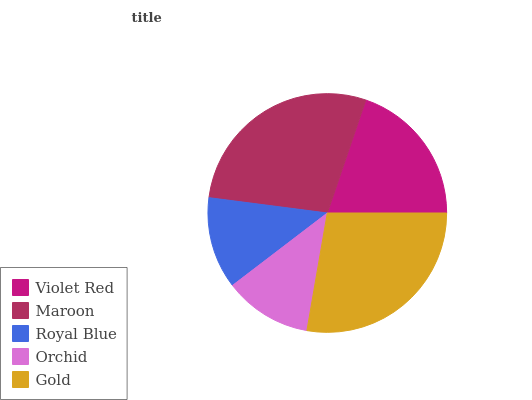Is Orchid the minimum?
Answer yes or no. Yes. Is Maroon the maximum?
Answer yes or no. Yes. Is Royal Blue the minimum?
Answer yes or no. No. Is Royal Blue the maximum?
Answer yes or no. No. Is Maroon greater than Royal Blue?
Answer yes or no. Yes. Is Royal Blue less than Maroon?
Answer yes or no. Yes. Is Royal Blue greater than Maroon?
Answer yes or no. No. Is Maroon less than Royal Blue?
Answer yes or no. No. Is Violet Red the high median?
Answer yes or no. Yes. Is Violet Red the low median?
Answer yes or no. Yes. Is Gold the high median?
Answer yes or no. No. Is Royal Blue the low median?
Answer yes or no. No. 